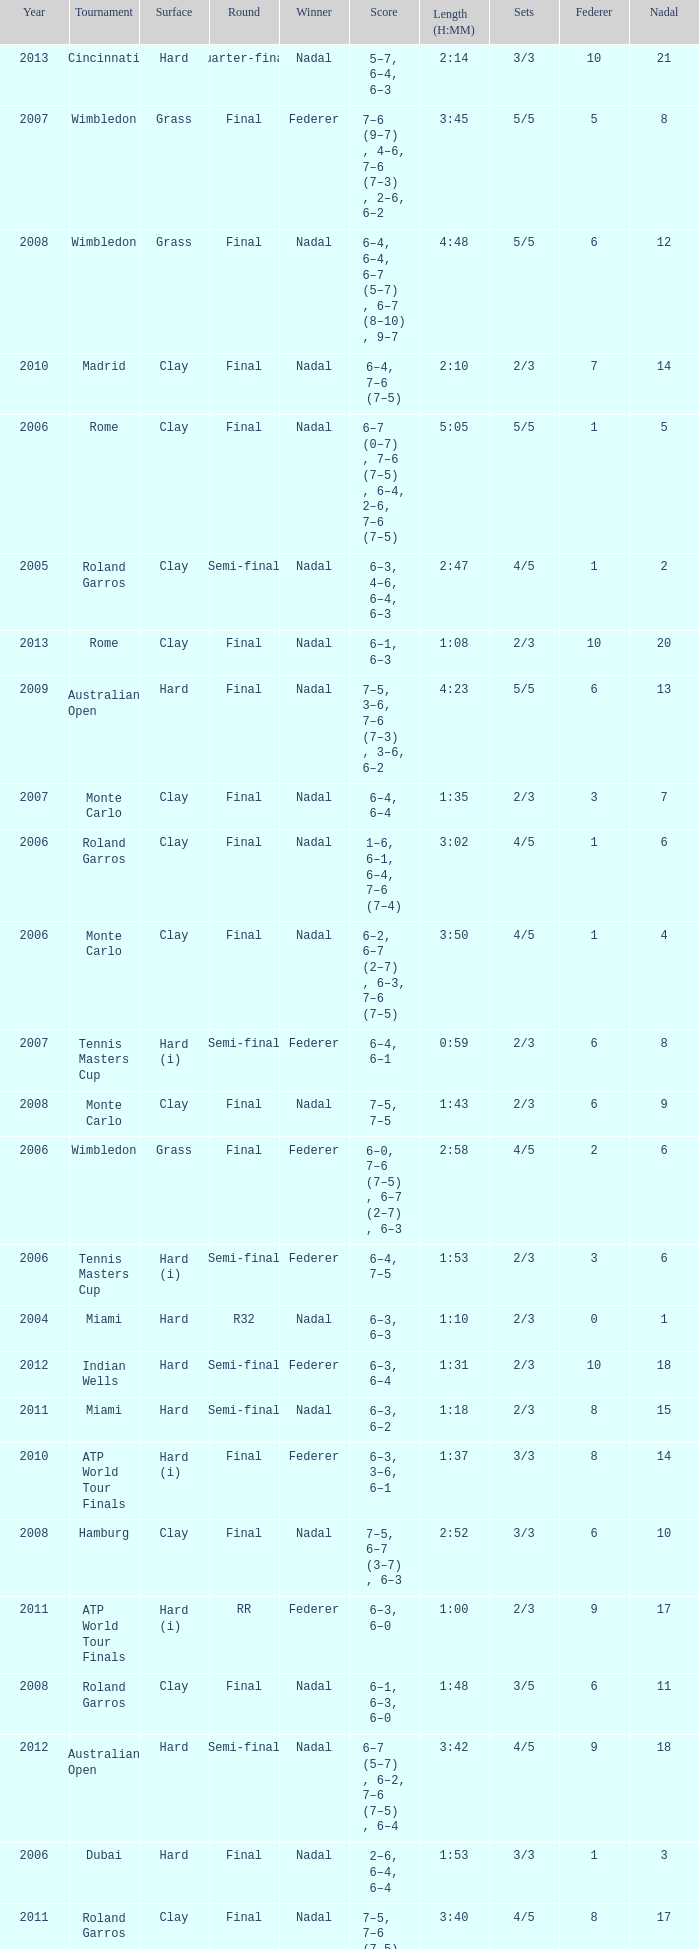What were the sets when Federer had 6 and a nadal of 13? 5/5. Would you mind parsing the complete table? {'header': ['Year', 'Tournament', 'Surface', 'Round', 'Winner', 'Score', 'Length (H:MM)', 'Sets', 'Federer', 'Nadal'], 'rows': [['2013', 'Cincinnati', 'Hard', 'Quarter-final', 'Nadal', '5–7, 6–4, 6–3', '2:14', '3/3', '10', '21'], ['2007', 'Wimbledon', 'Grass', 'Final', 'Federer', '7–6 (9–7) , 4–6, 7–6 (7–3) , 2–6, 6–2', '3:45', '5/5', '5', '8'], ['2008', 'Wimbledon', 'Grass', 'Final', 'Nadal', '6–4, 6–4, 6–7 (5–7) , 6–7 (8–10) , 9–7', '4:48', '5/5', '6', '12'], ['2010', 'Madrid', 'Clay', 'Final', 'Nadal', '6–4, 7–6 (7–5)', '2:10', '2/3', '7', '14'], ['2006', 'Rome', 'Clay', 'Final', 'Nadal', '6–7 (0–7) , 7–6 (7–5) , 6–4, 2–6, 7–6 (7–5)', '5:05', '5/5', '1', '5'], ['2005', 'Roland Garros', 'Clay', 'Semi-final', 'Nadal', '6–3, 4–6, 6–4, 6–3', '2:47', '4/5', '1', '2'], ['2013', 'Rome', 'Clay', 'Final', 'Nadal', '6–1, 6–3', '1:08', '2/3', '10', '20'], ['2009', 'Australian Open', 'Hard', 'Final', 'Nadal', '7–5, 3–6, 7–6 (7–3) , 3–6, 6–2', '4:23', '5/5', '6', '13'], ['2007', 'Monte Carlo', 'Clay', 'Final', 'Nadal', '6–4, 6–4', '1:35', '2/3', '3', '7'], ['2006', 'Roland Garros', 'Clay', 'Final', 'Nadal', '1–6, 6–1, 6–4, 7–6 (7–4)', '3:02', '4/5', '1', '6'], ['2006', 'Monte Carlo', 'Clay', 'Final', 'Nadal', '6–2, 6–7 (2–7) , 6–3, 7–6 (7–5)', '3:50', '4/5', '1', '4'], ['2007', 'Tennis Masters Cup', 'Hard (i)', 'Semi-final', 'Federer', '6–4, 6–1', '0:59', '2/3', '6', '8'], ['2008', 'Monte Carlo', 'Clay', 'Final', 'Nadal', '7–5, 7–5', '1:43', '2/3', '6', '9'], ['2006', 'Wimbledon', 'Grass', 'Final', 'Federer', '6–0, 7–6 (7–5) , 6–7 (2–7) , 6–3', '2:58', '4/5', '2', '6'], ['2006', 'Tennis Masters Cup', 'Hard (i)', 'Semi-final', 'Federer', '6–4, 7–5', '1:53', '2/3', '3', '6'], ['2004', 'Miami', 'Hard', 'R32', 'Nadal', '6–3, 6–3', '1:10', '2/3', '0', '1'], ['2012', 'Indian Wells', 'Hard', 'Semi-final', 'Federer', '6–3, 6–4', '1:31', '2/3', '10', '18'], ['2011', 'Miami', 'Hard', 'Semi-final', 'Nadal', '6–3, 6–2', '1:18', '2/3', '8', '15'], ['2010', 'ATP World Tour Finals', 'Hard (i)', 'Final', 'Federer', '6–3, 3–6, 6–1', '1:37', '3/3', '8', '14'], ['2008', 'Hamburg', 'Clay', 'Final', 'Nadal', '7–5, 6–7 (3–7) , 6–3', '2:52', '3/3', '6', '10'], ['2011', 'ATP World Tour Finals', 'Hard (i)', 'RR', 'Federer', '6–3, 6–0', '1:00', '2/3', '9', '17'], ['2008', 'Roland Garros', 'Clay', 'Final', 'Nadal', '6–1, 6–3, 6–0', '1:48', '3/5', '6', '11'], ['2012', 'Australian Open', 'Hard', 'Semi-final', 'Nadal', '6–7 (5–7) , 6–2, 7–6 (7–5) , 6–4', '3:42', '4/5', '9', '18'], ['2006', 'Dubai', 'Hard', 'Final', 'Nadal', '2–6, 6–4, 6–4', '1:53', '3/3', '1', '3'], ['2011', 'Roland Garros', 'Clay', 'Final', 'Nadal', '7–5, 7–6 (7–5) , 5–7, 6–1', '3:40', '4/5', '8', '17'], ['2013', 'Indian Wells', 'Hard', 'Quarter-final', 'Nadal', '6–4, 6–2', '1:24', '2/3', '10', '19'], ['2009', 'Madrid', 'Clay', 'Final', 'Federer', '6–4, 6–4', '1:26', '2/3', '7', '13'], ['2005', 'Miami', 'Hard', 'Final', 'Federer', '2–6, 6–7 (4–7) , 7–6 (7–5) , 6–3, 6–1', '3:43', '5/5', '1', '1'], ['2011', 'Madrid', 'Clay', 'Semi-final', 'Nadal', '5–7, 6–1, 6–3', '2:36', '3/3', '8', '16'], ['2007', 'Roland Garros', 'Clay', 'Final', 'Nadal', '6–3, 4–6, 6–3, 6–4', '3:10', '4/5', '4', '8'], ['2007', 'Hamburg', 'Clay', 'Final', 'Federer', '2–6, 6–2, 6–0', '1:55', '3/3', '4', '7']]} 